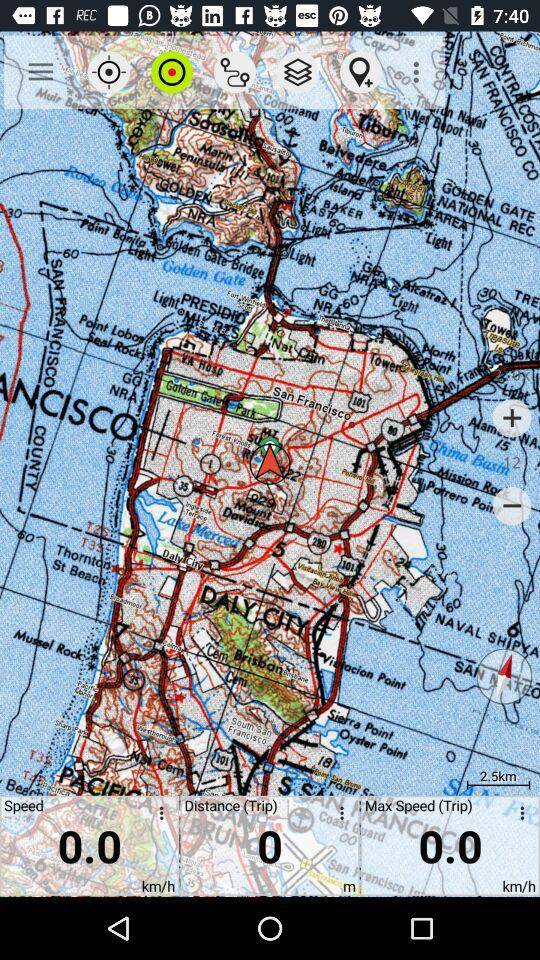What is the maximum speed? The maximum speed is 0.0 km/h. 